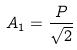Convert formula to latex. <formula><loc_0><loc_0><loc_500><loc_500>A _ { 1 } = \frac { P } { \sqrt { 2 } }</formula> 